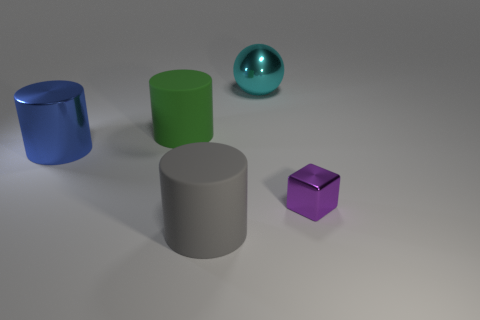Add 4 small purple metallic objects. How many objects exist? 9 Subtract all cubes. How many objects are left? 4 Add 5 gray things. How many gray things are left? 6 Add 1 brown metallic balls. How many brown metallic balls exist? 1 Subtract 0 brown balls. How many objects are left? 5 Subtract all yellow matte spheres. Subtract all tiny purple blocks. How many objects are left? 4 